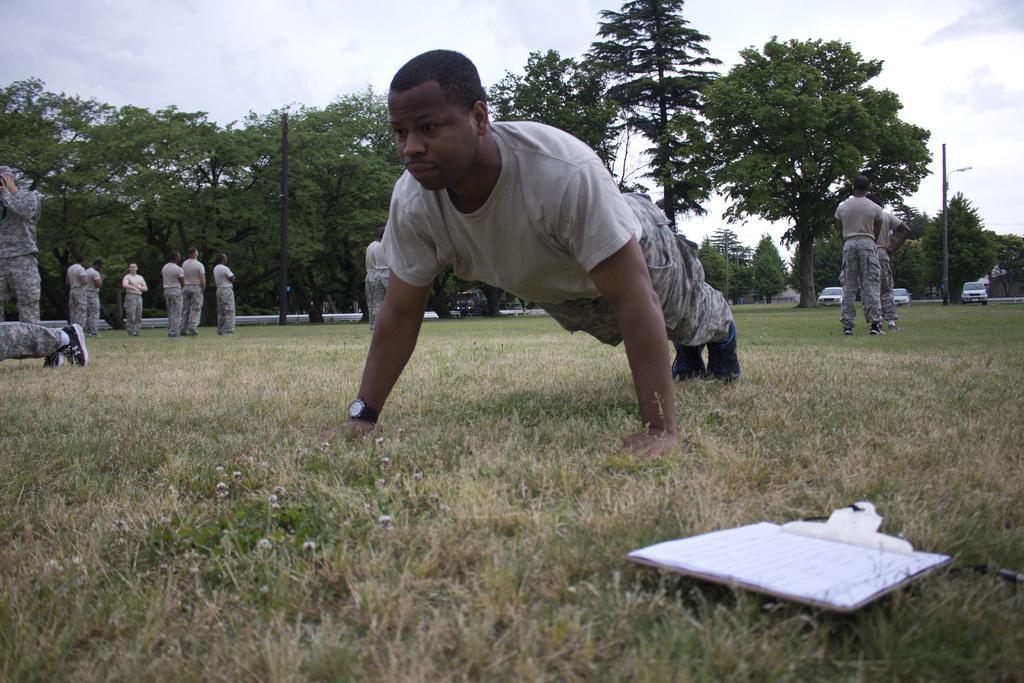How would you summarize this image in a sentence or two? There is a person doing an exercise. Here we can see few persons on the ground. There are trees, poles, vehicles, grass, and a book. In the background there is sky. 